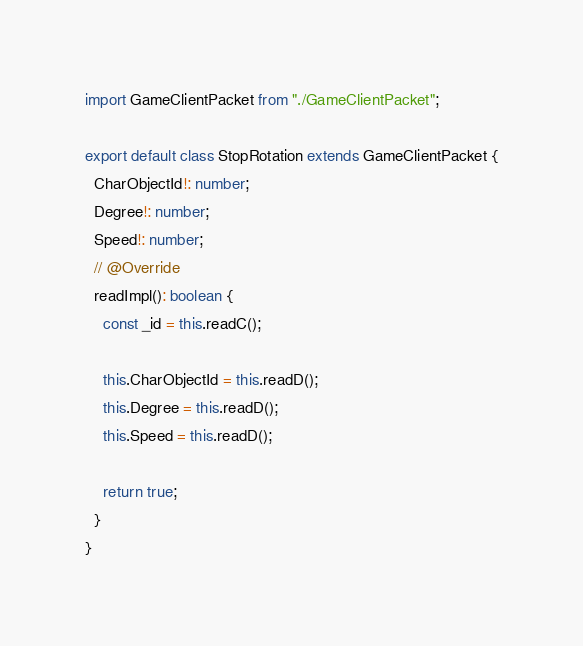Convert code to text. <code><loc_0><loc_0><loc_500><loc_500><_TypeScript_>import GameClientPacket from "./GameClientPacket";

export default class StopRotation extends GameClientPacket {
  CharObjectId!: number;
  Degree!: number;
  Speed!: number;
  // @Override
  readImpl(): boolean {
    const _id = this.readC();

    this.CharObjectId = this.readD();
    this.Degree = this.readD();
    this.Speed = this.readD();

    return true;
  }
}
</code> 